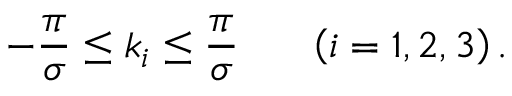<formula> <loc_0><loc_0><loc_500><loc_500>- { \frac { \pi } { \sigma } } \leq k _ { i } \leq { \frac { \pi } { \sigma } } \, \left ( i = 1 , 2 , 3 \right ) .</formula> 